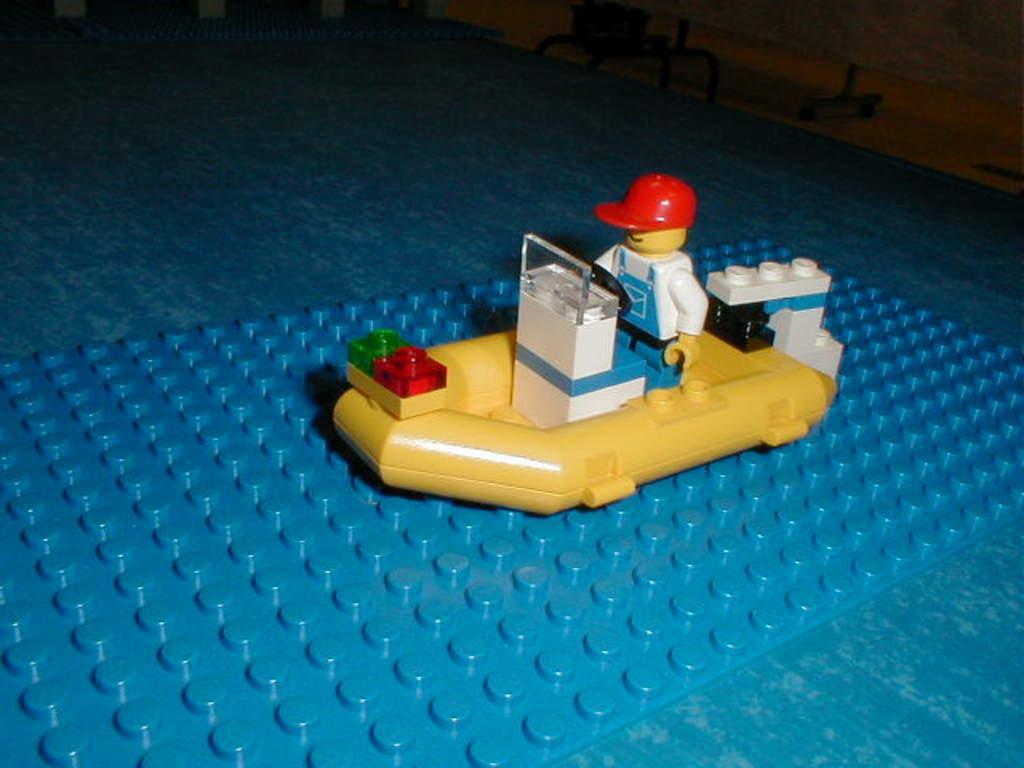What is the main object in the foreground of the image? There is a toy in the foreground of the image. What color is the surface on which the toy is placed? The toy is on a blue surface. What can be seen in the background of the image? There is a table in the background of the image. What type of whistle can be heard coming from the toy in the image? There is no whistle present in the image, and therefore no sound can be heard. 